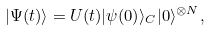Convert formula to latex. <formula><loc_0><loc_0><loc_500><loc_500>| \Psi ( t ) \rangle = U ( t ) | \psi ( 0 ) \rangle _ { C } | 0 \rangle ^ { \otimes N } ,</formula> 